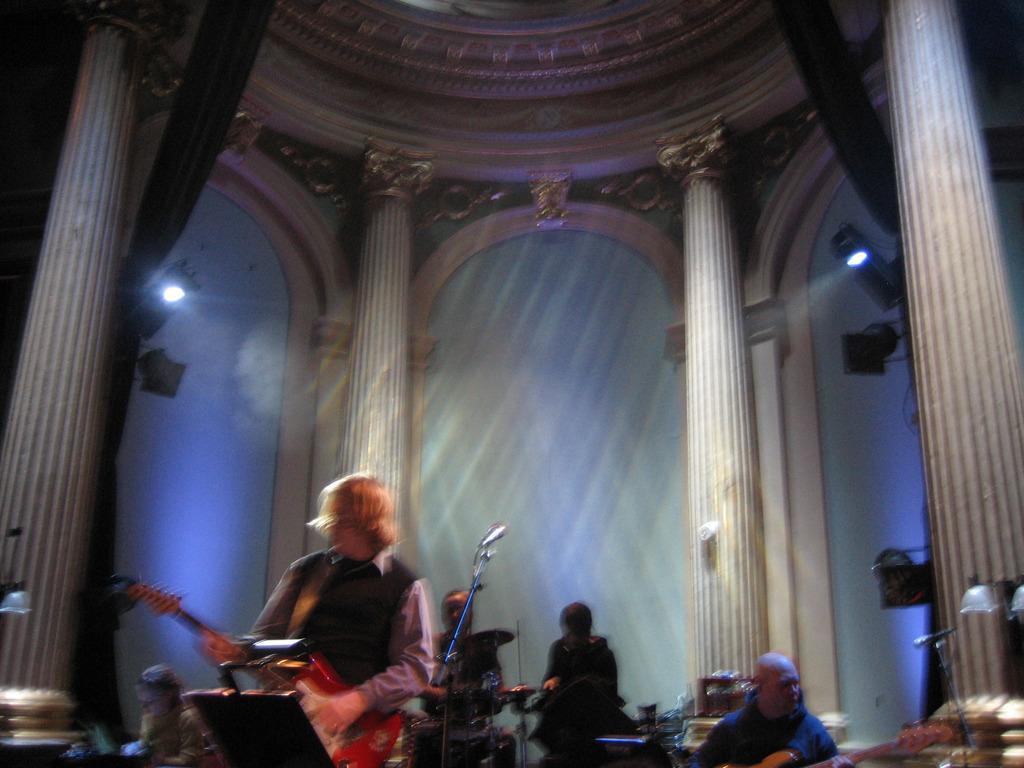Could you give a brief overview of what you see in this image? In the foreground of this image, that is a man standing and holding a guitar in front of a book holder and beside a mic stand. In the background, there are few people playing musical instruments and also we can see pillars, arches, lights and the curtains. 